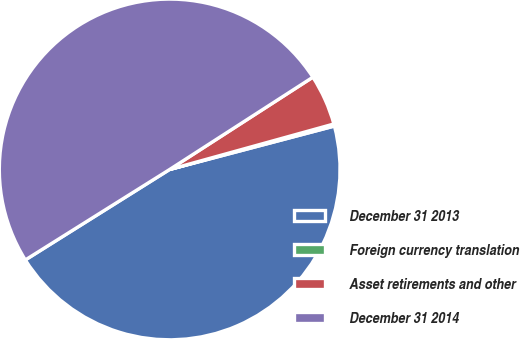<chart> <loc_0><loc_0><loc_500><loc_500><pie_chart><fcel>December 31 2013<fcel>Foreign currency translation<fcel>Asset retirements and other<fcel>December 31 2014<nl><fcel>45.19%<fcel>0.2%<fcel>4.81%<fcel>49.8%<nl></chart> 